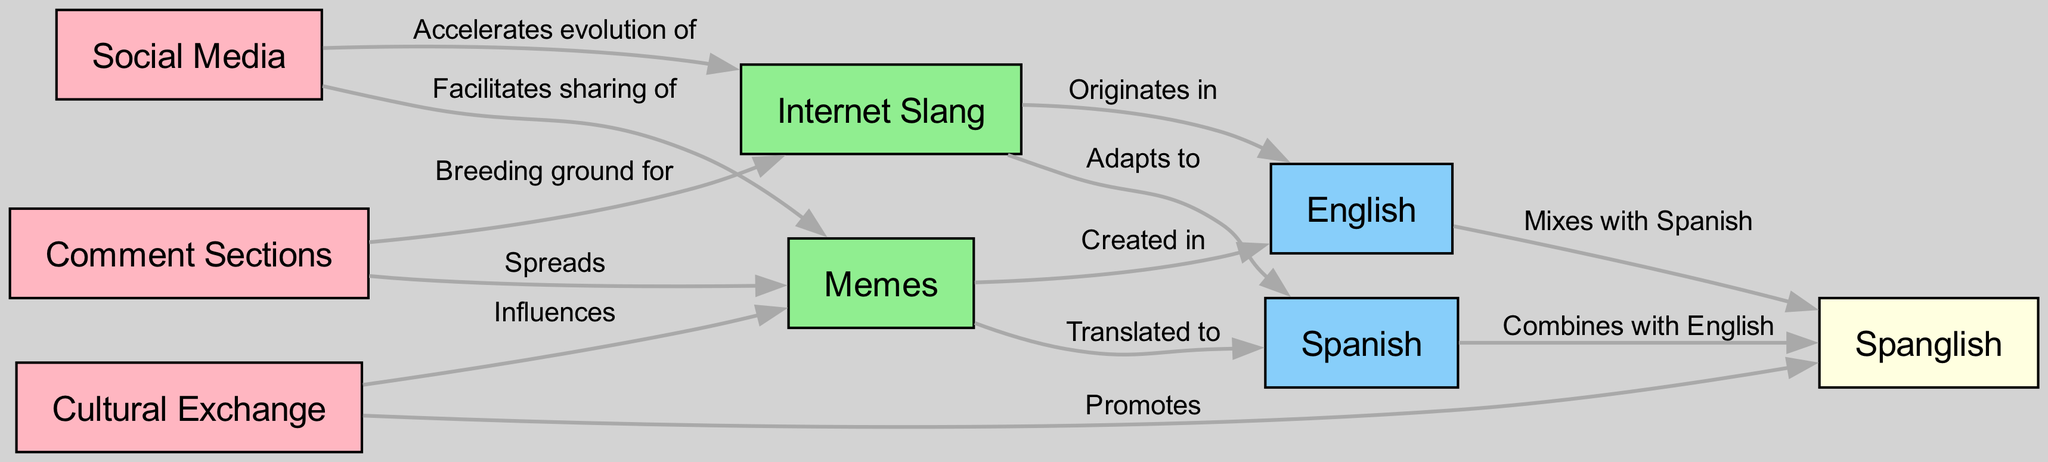What is the label of the node that corresponds to "Internet Slang"? The node labeled "Internet Slang" corresponds directly to its identity as indicated in the diagram.
Answer: Internet Slang How many nodes are there in total in the diagram? Counting all the listed nodes: internet_slang, memes, spanish, english, spanglish, comment_sections, social_media, and cultural_exchange, gives a total of 8 nodes.
Answer: 8 Which language is shown to have memes created in it? The diagram indicates that memes have been "Created in" English, providing a direct connection from the memes node to the English node.
Answer: English What type of exchange promotes Spanglish in the diagram? The edge labeled "Promotes" connects cultural_exchange to spanglish, indicating that the cultural exchange is the type that promotes Spanglish.
Answer: Cultural Exchange How does social media influence internet slang according to the diagram? The diagram details that social_media "Accelerates evolution of" internet_slang, showing a direct relationship that indicates social media's influence.
Answer: Accelerates evolution of What is the relationship between comment sections and memes? The diagram shows that comment_sections "Spreads" memes, as indicated in the connection with this label.
Answer: Spreads Which two languages combine to form Spanglish? The diagram illustrates that both Spanish and English combine to form Spanglish, as seen in separate edges leading to the spanglish node.
Answer: Spanish and English How is the sharing of memes facilitated according to the diagram? The diagram indicates that social_media "Facilitates sharing of" memes, directly connecting the two nodes under this label.
Answer: Facilitates sharing of 